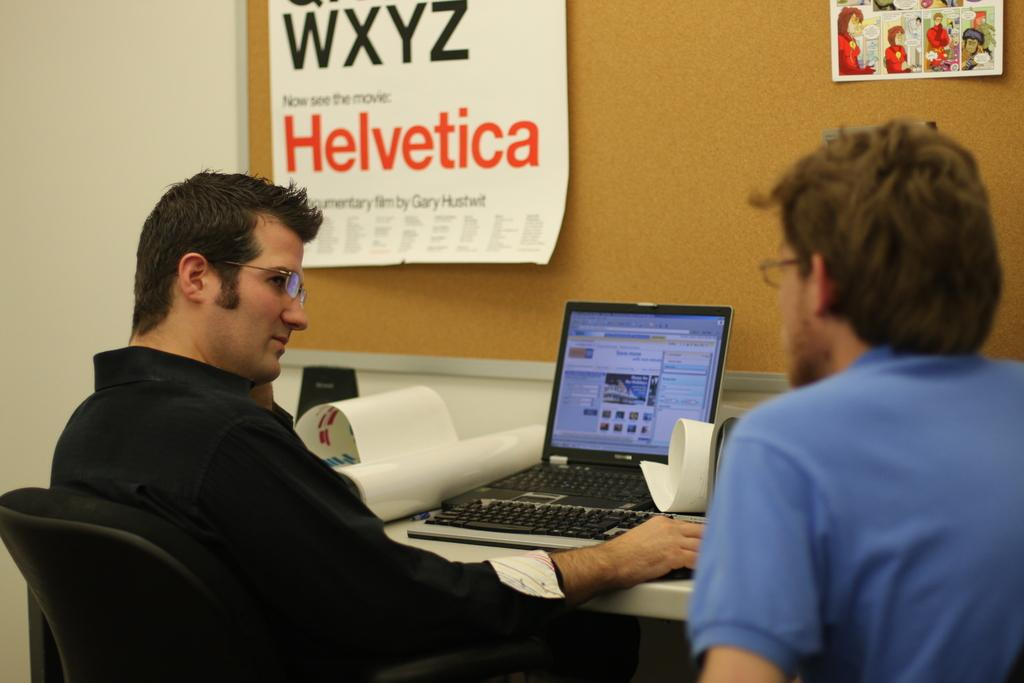<image>
Share a concise interpretation of the image provided. A poster on a wall mentioning a movie called "Helvetica". 